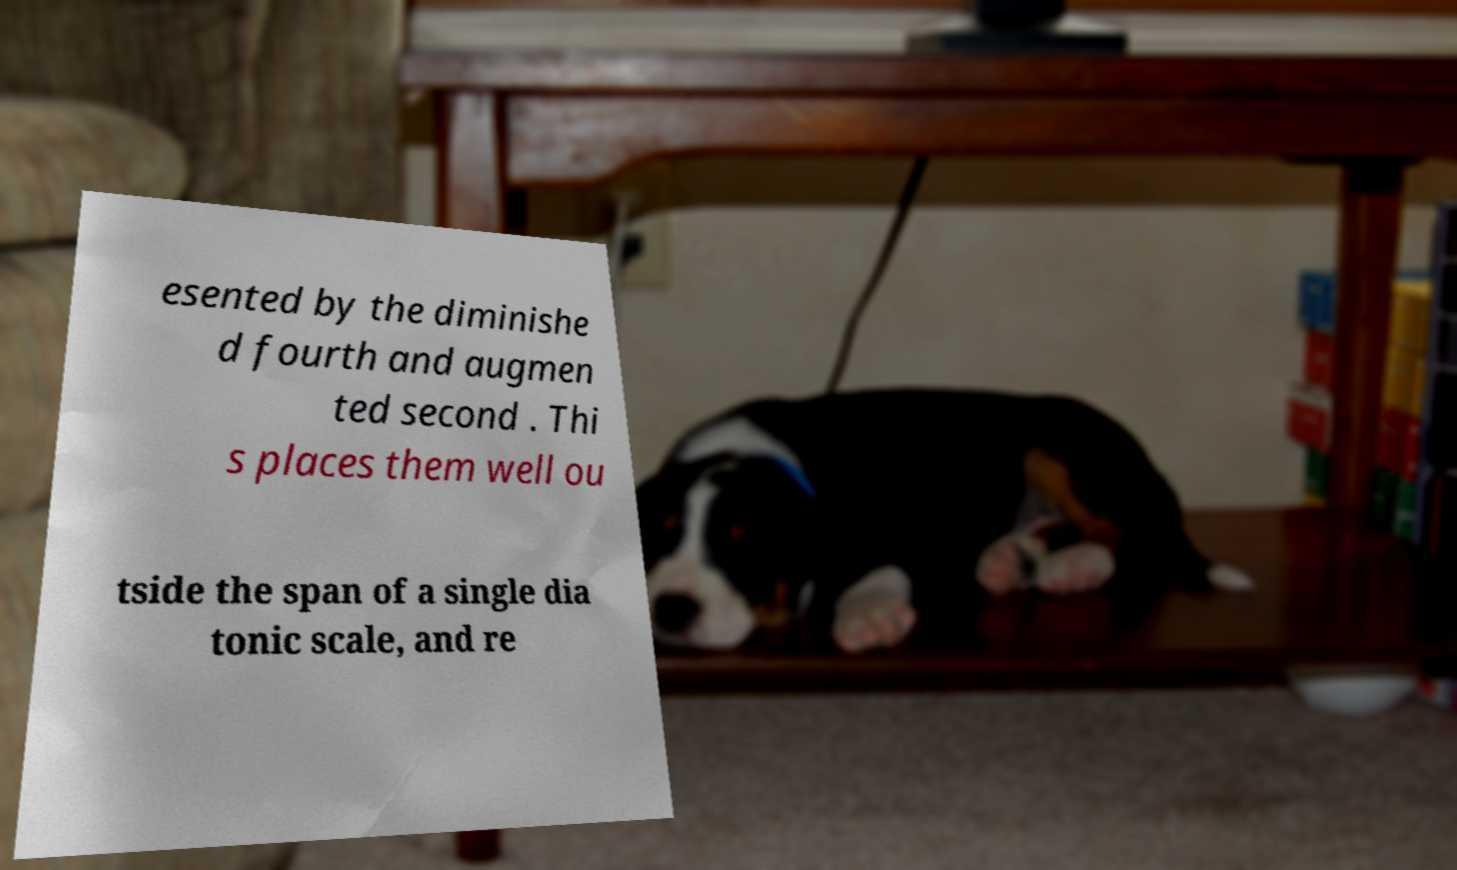Could you extract and type out the text from this image? esented by the diminishe d fourth and augmen ted second . Thi s places them well ou tside the span of a single dia tonic scale, and re 